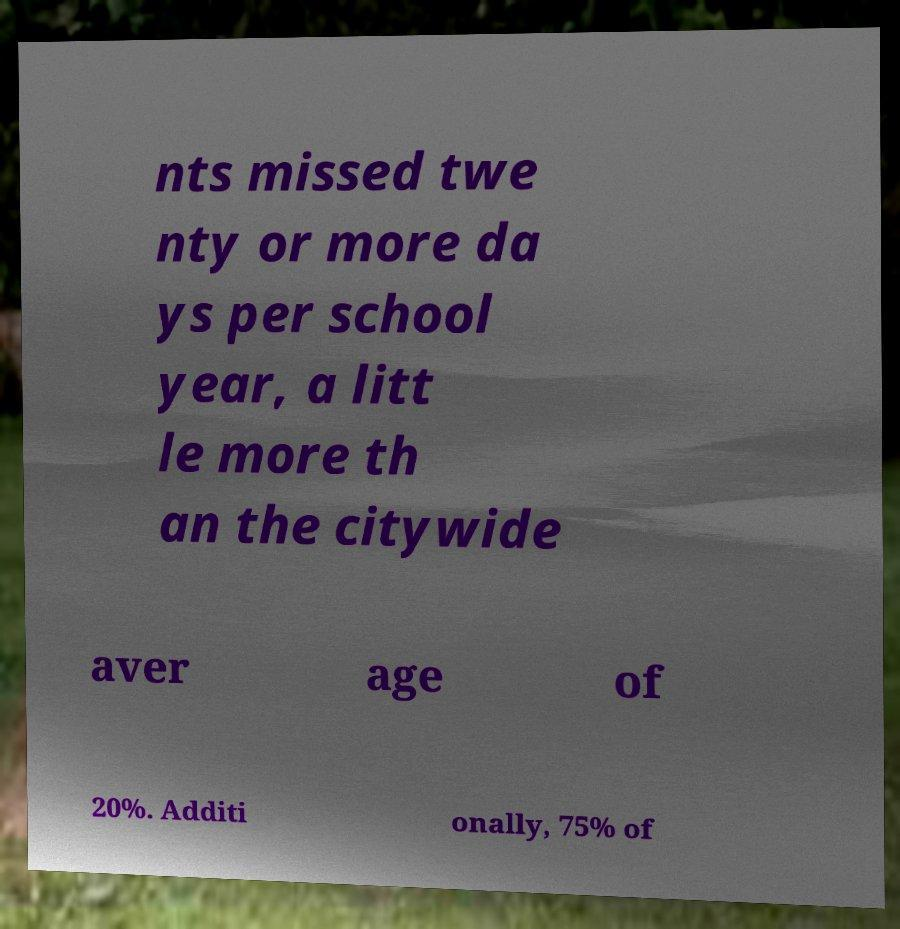Please read and relay the text visible in this image. What does it say? nts missed twe nty or more da ys per school year, a litt le more th an the citywide aver age of 20%. Additi onally, 75% of 